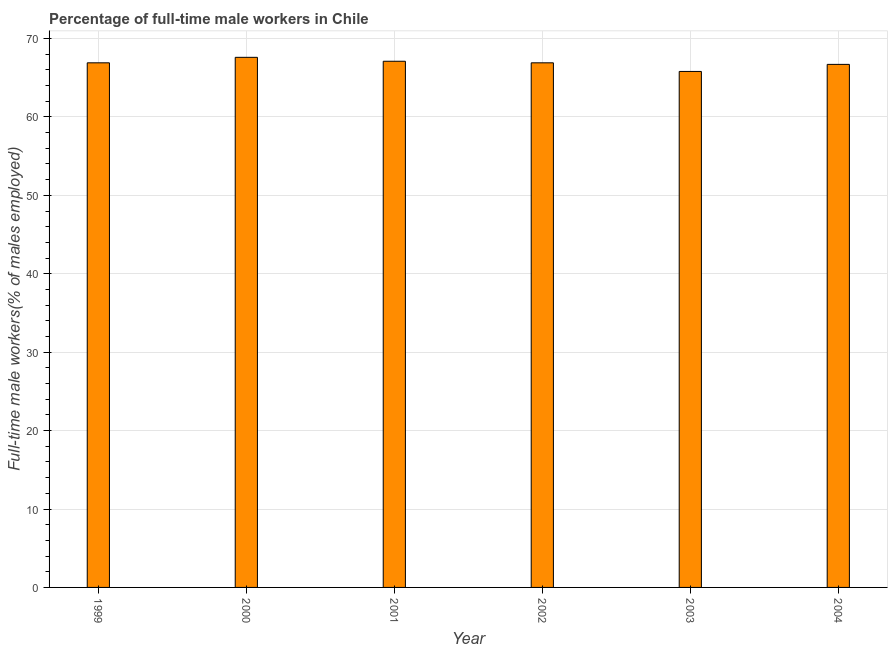Does the graph contain any zero values?
Your answer should be compact. No. What is the title of the graph?
Ensure brevity in your answer.  Percentage of full-time male workers in Chile. What is the label or title of the X-axis?
Offer a very short reply. Year. What is the label or title of the Y-axis?
Your answer should be compact. Full-time male workers(% of males employed). What is the percentage of full-time male workers in 2002?
Ensure brevity in your answer.  66.9. Across all years, what is the maximum percentage of full-time male workers?
Your answer should be compact. 67.6. Across all years, what is the minimum percentage of full-time male workers?
Your response must be concise. 65.8. In which year was the percentage of full-time male workers minimum?
Your answer should be compact. 2003. What is the sum of the percentage of full-time male workers?
Your answer should be compact. 401. What is the average percentage of full-time male workers per year?
Offer a very short reply. 66.83. What is the median percentage of full-time male workers?
Offer a terse response. 66.9. In how many years, is the percentage of full-time male workers greater than 28 %?
Provide a succinct answer. 6. Do a majority of the years between 1999 and 2000 (inclusive) have percentage of full-time male workers greater than 62 %?
Offer a terse response. Yes. Is the percentage of full-time male workers in 2003 less than that in 2004?
Offer a terse response. Yes. What is the difference between the highest and the second highest percentage of full-time male workers?
Make the answer very short. 0.5. Is the sum of the percentage of full-time male workers in 1999 and 2000 greater than the maximum percentage of full-time male workers across all years?
Your response must be concise. Yes. What is the difference between the highest and the lowest percentage of full-time male workers?
Give a very brief answer. 1.8. Are all the bars in the graph horizontal?
Offer a very short reply. No. What is the difference between two consecutive major ticks on the Y-axis?
Offer a very short reply. 10. Are the values on the major ticks of Y-axis written in scientific E-notation?
Your response must be concise. No. What is the Full-time male workers(% of males employed) in 1999?
Offer a terse response. 66.9. What is the Full-time male workers(% of males employed) in 2000?
Offer a very short reply. 67.6. What is the Full-time male workers(% of males employed) in 2001?
Offer a terse response. 67.1. What is the Full-time male workers(% of males employed) in 2002?
Make the answer very short. 66.9. What is the Full-time male workers(% of males employed) of 2003?
Keep it short and to the point. 65.8. What is the Full-time male workers(% of males employed) in 2004?
Give a very brief answer. 66.7. What is the difference between the Full-time male workers(% of males employed) in 1999 and 2000?
Offer a terse response. -0.7. What is the difference between the Full-time male workers(% of males employed) in 1999 and 2002?
Your response must be concise. 0. What is the difference between the Full-time male workers(% of males employed) in 1999 and 2003?
Offer a terse response. 1.1. What is the difference between the Full-time male workers(% of males employed) in 2000 and 2003?
Offer a very short reply. 1.8. What is the difference between the Full-time male workers(% of males employed) in 2000 and 2004?
Keep it short and to the point. 0.9. What is the difference between the Full-time male workers(% of males employed) in 2001 and 2002?
Provide a short and direct response. 0.2. What is the difference between the Full-time male workers(% of males employed) in 2001 and 2003?
Offer a terse response. 1.3. What is the difference between the Full-time male workers(% of males employed) in 2001 and 2004?
Provide a short and direct response. 0.4. What is the difference between the Full-time male workers(% of males employed) in 2002 and 2003?
Provide a short and direct response. 1.1. What is the difference between the Full-time male workers(% of males employed) in 2003 and 2004?
Ensure brevity in your answer.  -0.9. What is the ratio of the Full-time male workers(% of males employed) in 1999 to that in 2001?
Offer a very short reply. 1. What is the ratio of the Full-time male workers(% of males employed) in 1999 to that in 2002?
Provide a short and direct response. 1. What is the ratio of the Full-time male workers(% of males employed) in 1999 to that in 2003?
Your answer should be compact. 1.02. What is the ratio of the Full-time male workers(% of males employed) in 1999 to that in 2004?
Offer a terse response. 1. What is the ratio of the Full-time male workers(% of males employed) in 2000 to that in 2001?
Offer a terse response. 1.01. What is the ratio of the Full-time male workers(% of males employed) in 2000 to that in 2002?
Give a very brief answer. 1.01. What is the ratio of the Full-time male workers(% of males employed) in 2000 to that in 2003?
Keep it short and to the point. 1.03. What is the ratio of the Full-time male workers(% of males employed) in 2001 to that in 2002?
Keep it short and to the point. 1. What is the ratio of the Full-time male workers(% of males employed) in 2001 to that in 2003?
Ensure brevity in your answer.  1.02. What is the ratio of the Full-time male workers(% of males employed) in 2001 to that in 2004?
Give a very brief answer. 1.01. What is the ratio of the Full-time male workers(% of males employed) in 2002 to that in 2004?
Provide a succinct answer. 1. What is the ratio of the Full-time male workers(% of males employed) in 2003 to that in 2004?
Keep it short and to the point. 0.99. 